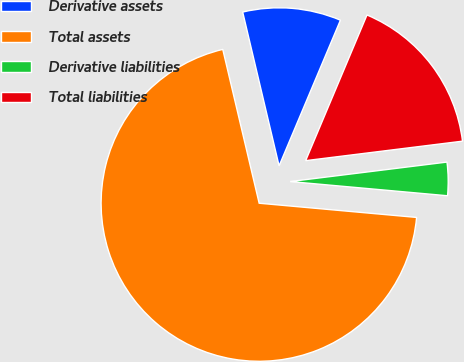Convert chart to OTSL. <chart><loc_0><loc_0><loc_500><loc_500><pie_chart><fcel>Derivative assets<fcel>Total assets<fcel>Derivative liabilities<fcel>Total liabilities<nl><fcel>10.04%<fcel>69.87%<fcel>3.4%<fcel>16.69%<nl></chart> 